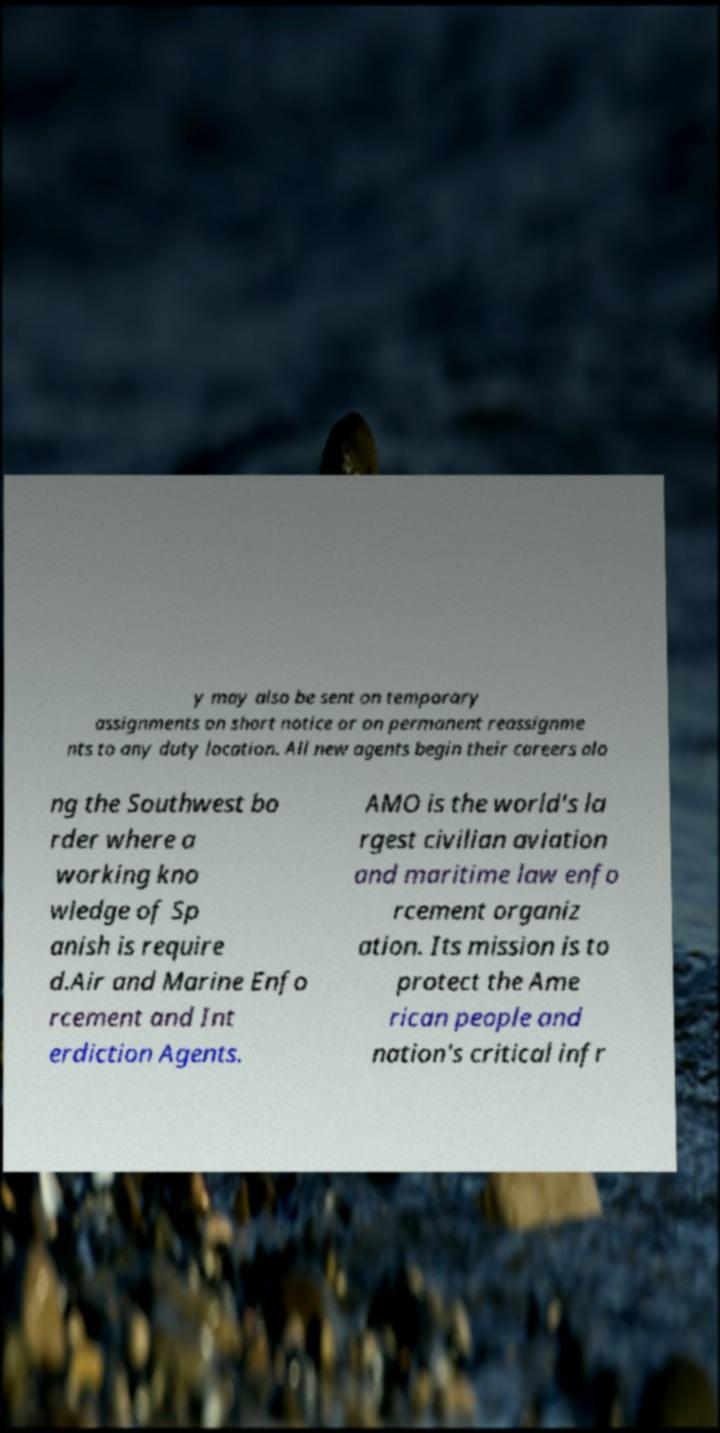I need the written content from this picture converted into text. Can you do that? y may also be sent on temporary assignments on short notice or on permanent reassignme nts to any duty location. All new agents begin their careers alo ng the Southwest bo rder where a working kno wledge of Sp anish is require d.Air and Marine Enfo rcement and Int erdiction Agents. AMO is the world's la rgest civilian aviation and maritime law enfo rcement organiz ation. Its mission is to protect the Ame rican people and nation's critical infr 